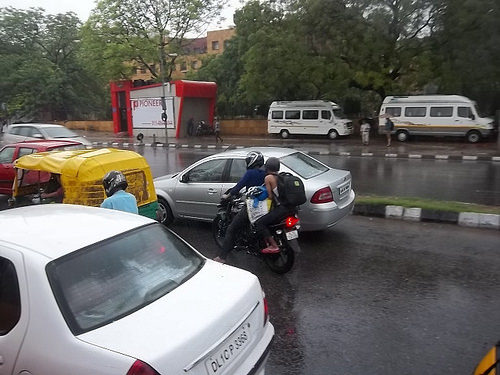<image>
Is the woman behind the man? Yes. From this viewpoint, the woman is positioned behind the man, with the man partially or fully occluding the woman. 